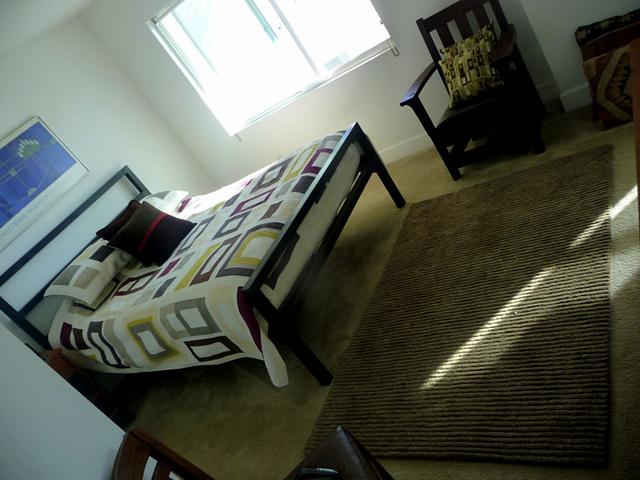Is this a boys room or a girls?
Short answer required. Boys. What room is this?
Be succinct. Bedroom. What color small pillow is on the bed?
Answer briefly. Black. What age group does this bedroom looks like it belongs to?
Quick response, please. Teen. Is this room tidy?
Give a very brief answer. Yes. 